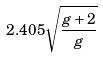<formula> <loc_0><loc_0><loc_500><loc_500>2 . 4 0 5 \sqrt { \frac { g + 2 } { g } }</formula> 